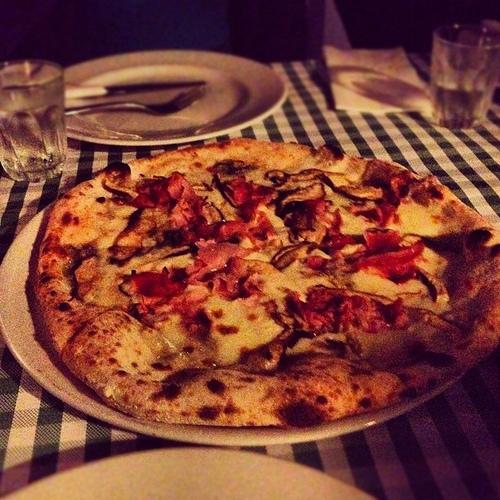Examine the image and determine if there are any empty plates visible. Yes, there is a clean, empty white plate next to the pizza on the table. What type of tablecloth is in the image and how would you describe the pattern? The tablecloth in the image is a green and white checkered pattern that covers the entire table. Describe the appearance of the pizza in the image. The pizza has a thick, fluffy crust with a small brown burn spot, and is topped with cheese, different meaty toppings, and a pink fleshy pizza topping. Identify the objects on the table apart from the pizza. Apart from the pizza, there is a half full glass of water, a folded white napkin, and a shiny set of silverware with a fork and knife on the table. Analyze the interaction between objects in the image, focusing on their placement and relation to each other. The pizza occupies the center of the image, with the utensils, napkin, and glass placed around it on the table, while everything is arranged on the checkered tablecloth, suggesting a cozy and inviting dining setup. Assess the quality of the image based on the objects' visibility and positioning. The image quality is good as objects are visible and well-positioned, providing a clear view of the pizza, utensils, glass, napkin, and tablecloth. List the objects found on the table and their corresponding colors. Objects on the table include a white plate, green and white checkered tablecloth, white napkin, silver fork and knife, and a colorless glass of water. How many prongs are visible on the fork in the image? There are four prongs visible on the fork in the image. Provide a brief overview of the main elements in the image. The image depicts a delicious pizza on a white plate surrounded by a half full glass of water, a folded napkin, fork, and knife on a green and white checkered tablecloth. How would you describe the sentiment expressed by this image? The sentiment expressed by this image is one of enjoyment and satisfaction, as the delicious looking pizza with various toppings represents a tasty meal. Is there a black napkin on the table next to the glass? The napkin mentioned in the image is actually white, not black. There is a small black shadow on the white napkin, but the napkin itself is not black. Does the knife have a red handle on the plate? The knife mentioned in the image has a white handle, not a red handle. Is the tablecloth blue and yellow in the image? The tablecloth mentioned in the image is actually green and white, not blue and yellow. Can you see a full glass of water on the table next to the pizza? The glass of water mentioned in the image is actually half full, not completely full. Is the plate beneath the pizza purple in color? The plate mentioned in the image is described as being white, not purple. Are there vegetables on the pizza? The image mentions the pizza having meaty toppings, but no vegetables are mentioned. 